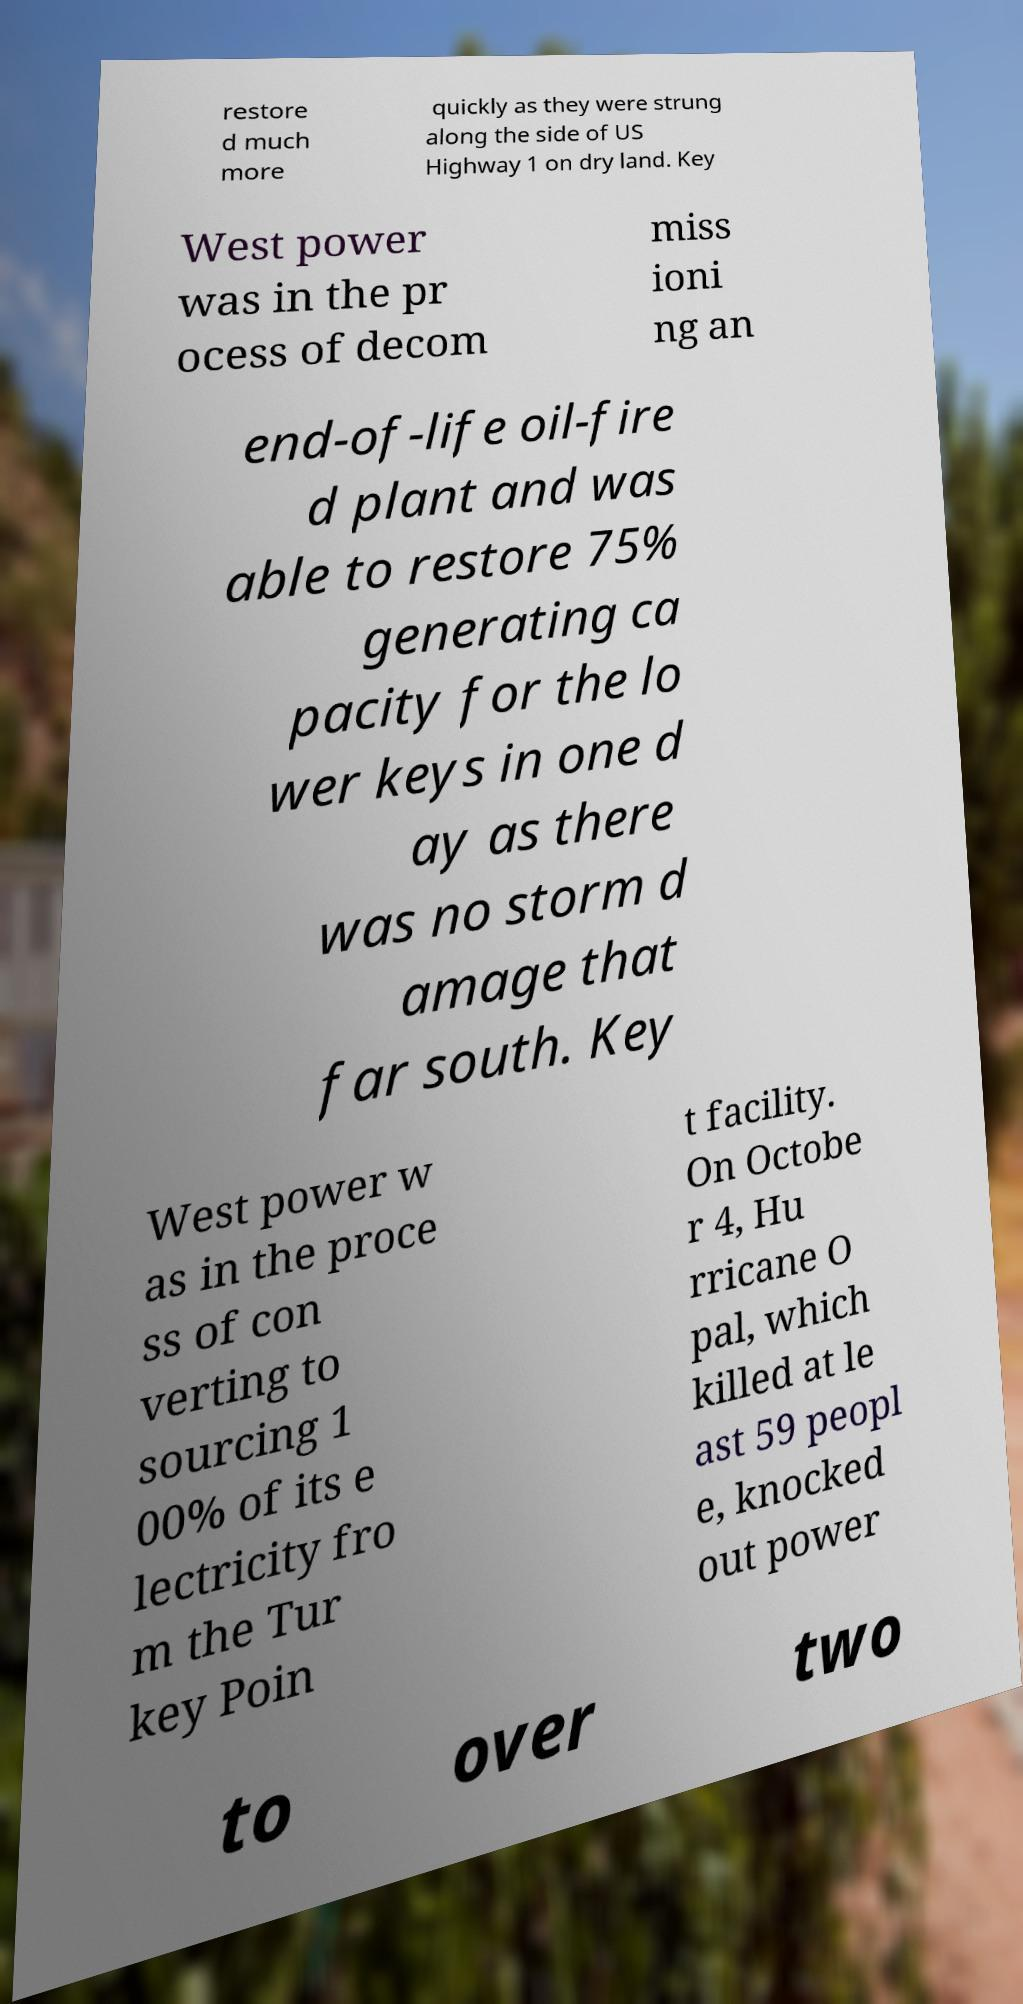Can you read and provide the text displayed in the image?This photo seems to have some interesting text. Can you extract and type it out for me? restore d much more quickly as they were strung along the side of US Highway 1 on dry land. Key West power was in the pr ocess of decom miss ioni ng an end-of-life oil-fire d plant and was able to restore 75% generating ca pacity for the lo wer keys in one d ay as there was no storm d amage that far south. Key West power w as in the proce ss of con verting to sourcing 1 00% of its e lectricity fro m the Tur key Poin t facility. On Octobe r 4, Hu rricane O pal, which killed at le ast 59 peopl e, knocked out power to over two 